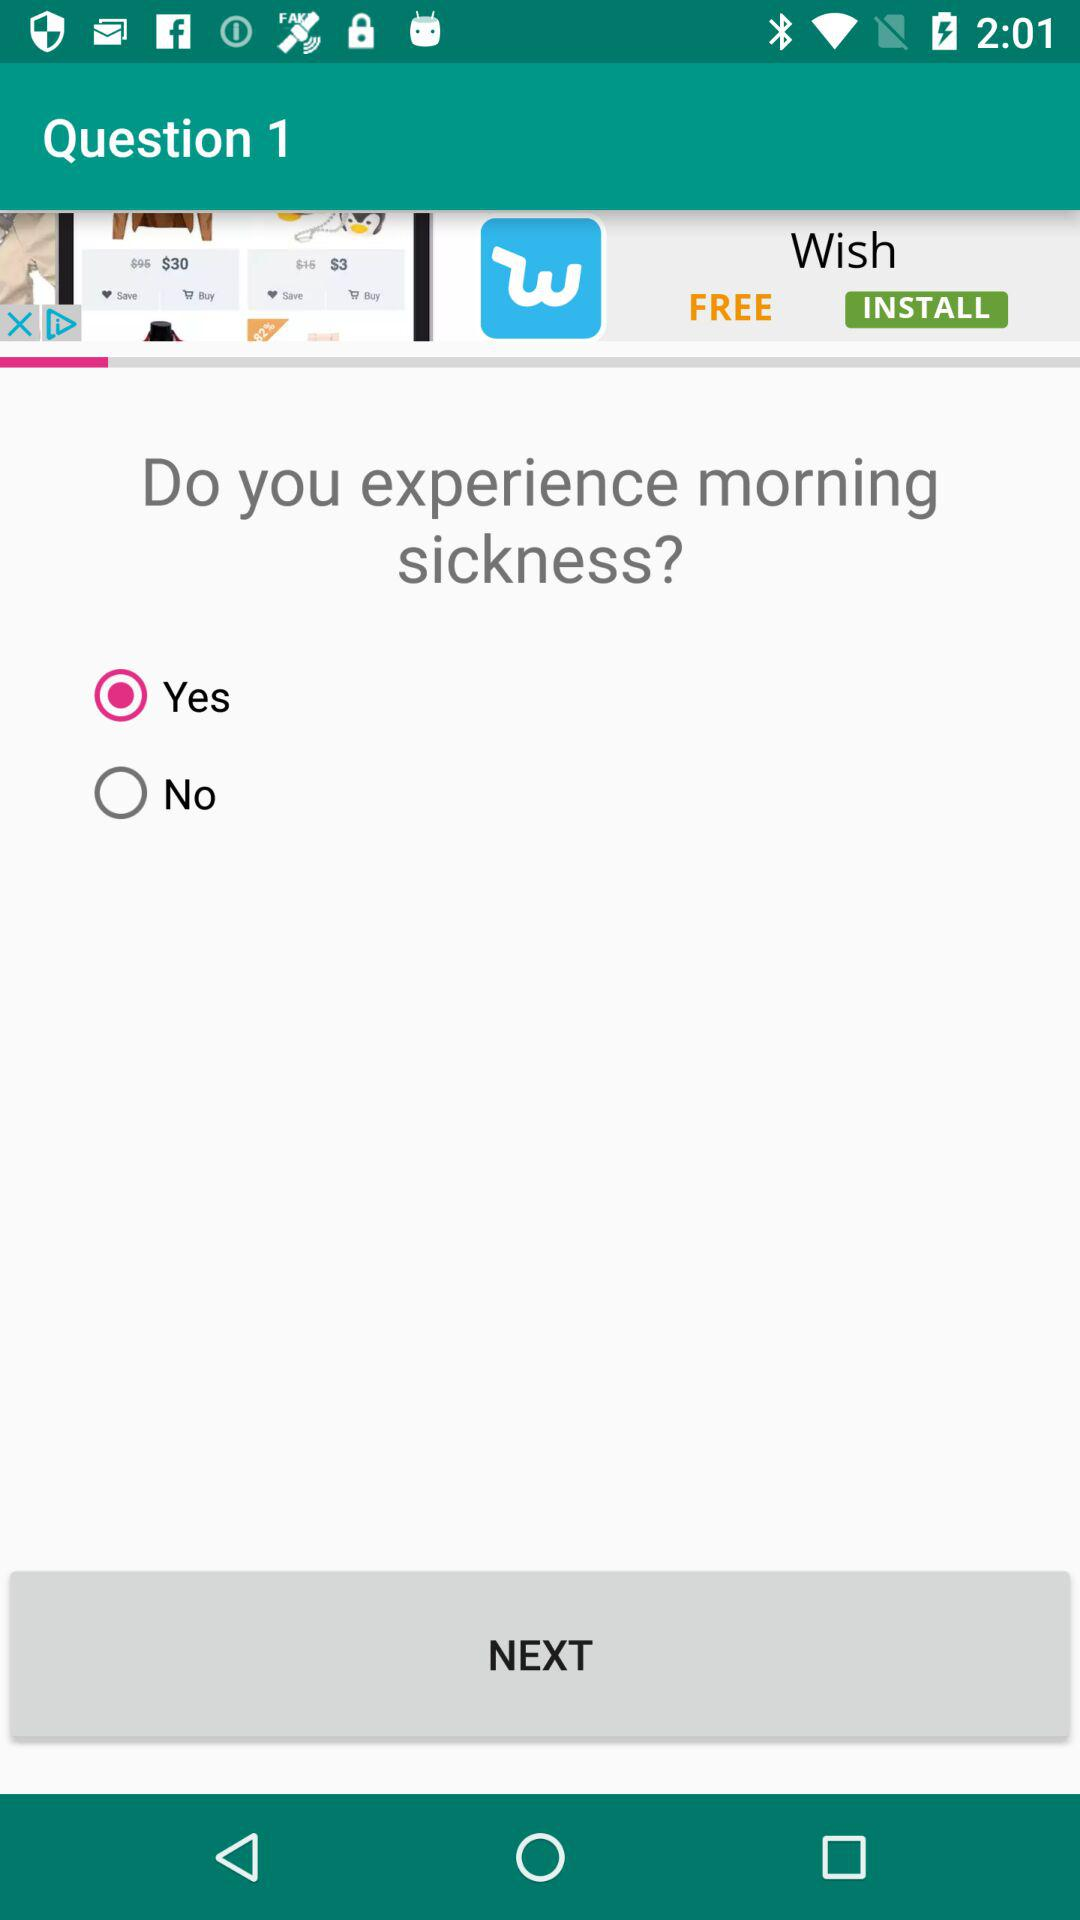Which option is selected? The selected option is "Yes". 